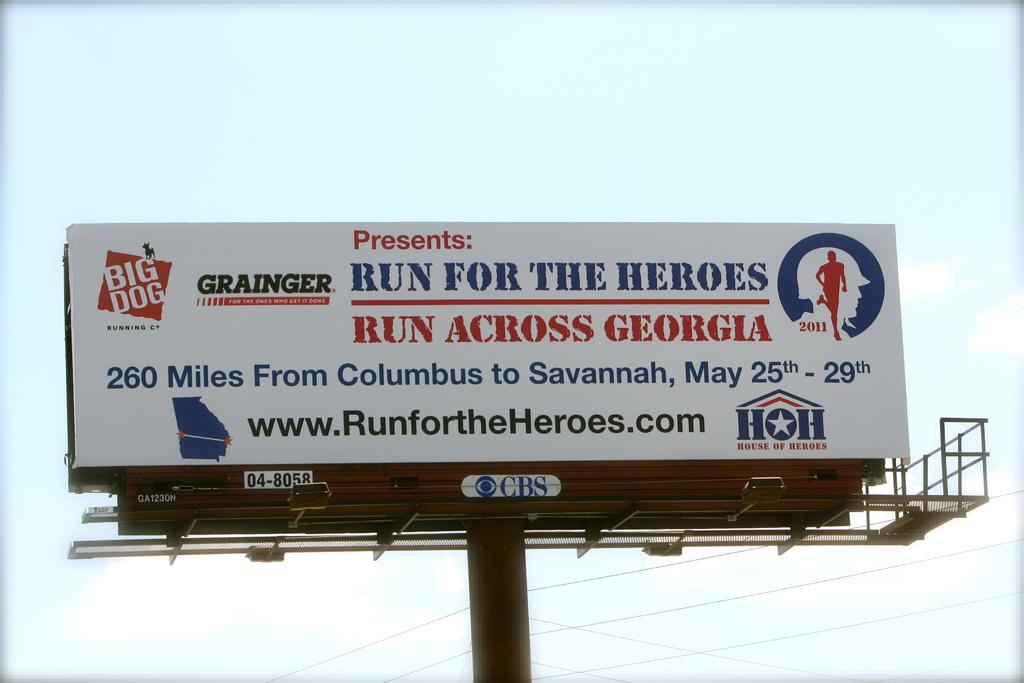What are the dates of this run?
Give a very brief answer. May 25-29. 